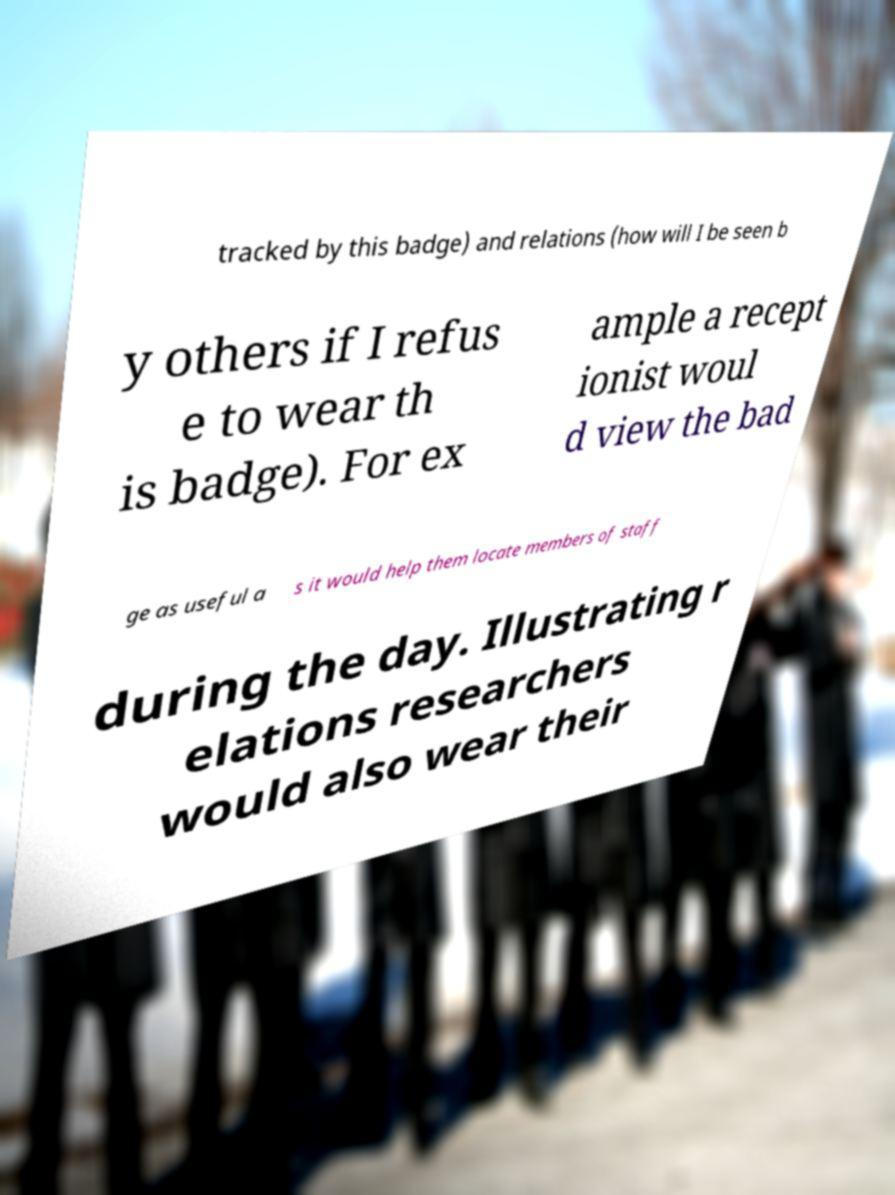Please read and relay the text visible in this image. What does it say? tracked by this badge) and relations (how will I be seen b y others if I refus e to wear th is badge). For ex ample a recept ionist woul d view the bad ge as useful a s it would help them locate members of staff during the day. Illustrating r elations researchers would also wear their 